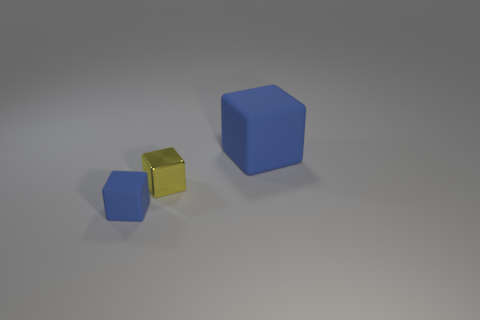What number of other things are there of the same shape as the yellow object?
Offer a very short reply. 2. There is a rubber object that is behind the small matte object; is its color the same as the tiny metallic cube behind the tiny blue matte object?
Make the answer very short. No. There is a blue object behind the tiny blue block; does it have the same size as the blue rubber block left of the large blue rubber thing?
Your answer should be very brief. No. Are there any other things that are made of the same material as the tiny blue thing?
Your response must be concise. Yes. What is the blue object behind the small blue object left of the blue cube behind the small blue rubber cube made of?
Give a very brief answer. Rubber. Does the large blue matte object have the same shape as the tiny shiny object?
Your answer should be very brief. Yes. What is the material of the small yellow thing that is the same shape as the big blue thing?
Give a very brief answer. Metal. What number of large things are the same color as the small matte cube?
Provide a succinct answer. 1. What size is the other blue block that is made of the same material as the tiny blue cube?
Your answer should be compact. Large. What number of brown objects are either tiny metallic blocks or rubber objects?
Provide a succinct answer. 0. 